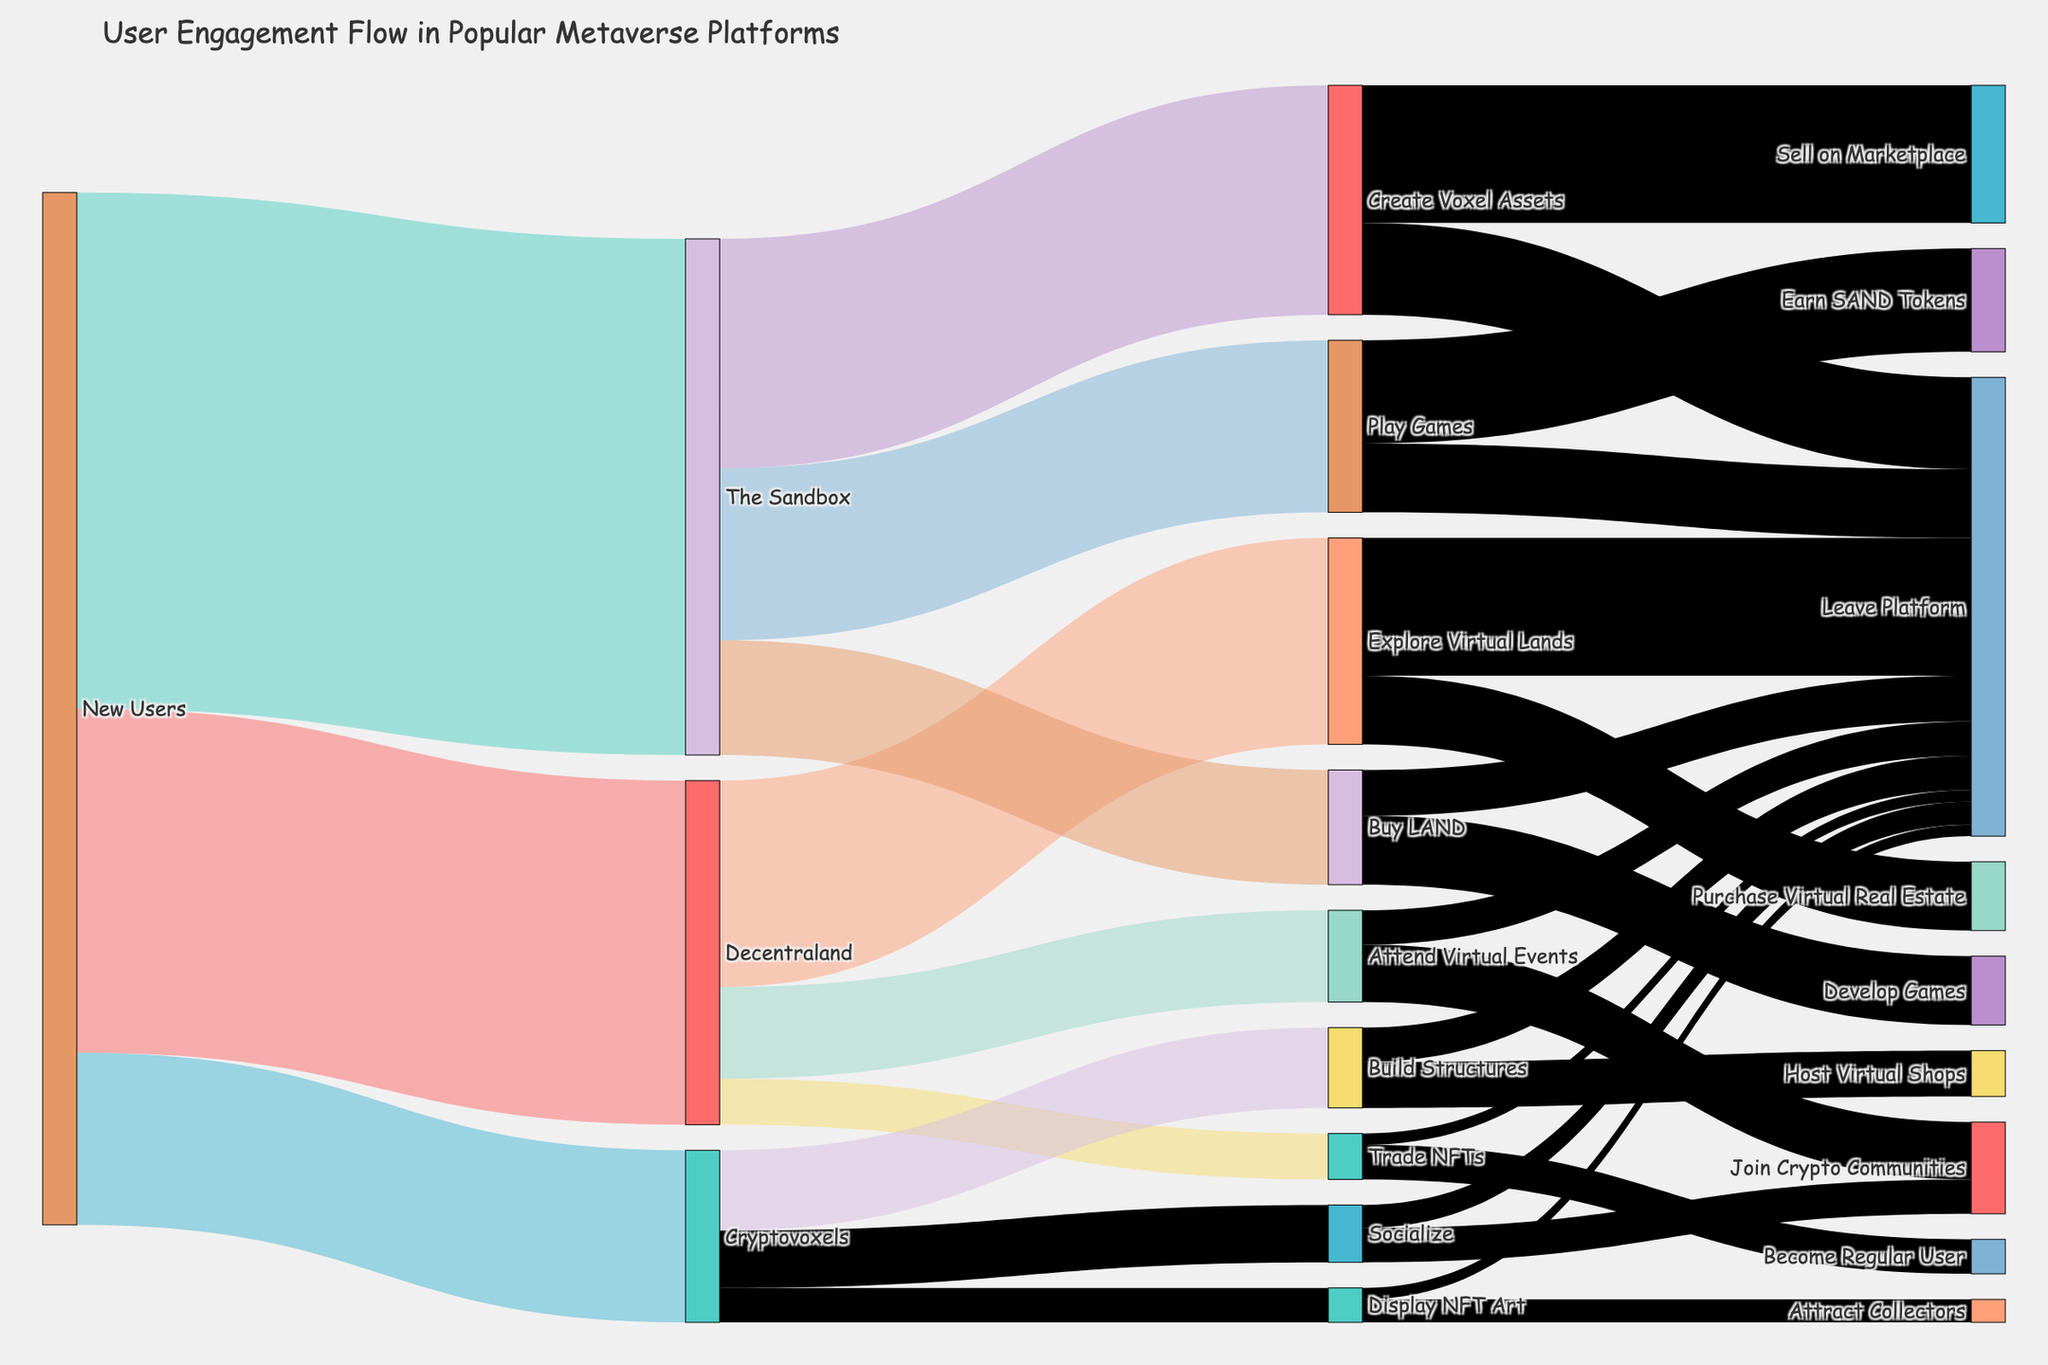What is the title of the figure? The title of the figure is displayed at the top of the Sankey diagram. By reading the top section, you can identify the title.
Answer: User Engagement Flow in Popular Metaverse Platforms Which metaverse platform has the highest number of new users engaging initially? Look for the nodes labeled with the respective metaverse platforms connecting from 'New Users' and compare their values. The node with the highest value indicates the platform with the most new users.
Answer: The Sandbox What is the most common activity for new users in Decentraland? Identify the activities connected from 'Decentraland' and find the one with the highest value.
Answer: Explore Virtual Lands How many users join crypto communities after attending virtual events in Decentraland? Find the node 'Attend Virtual Events' under 'Decentraland' and follow the arrow leading to 'Join Crypto Communities'. Refer to its value.
Answer: 500 What is the total number of new users across all metaverse platforms? Sum the values of new users for all metaverse platforms.
Answer: 9000 Between 'Play Games' and 'Create Voxel Assets' in The Sandbox, which activity has more user engagement? Identify the values connected to 'Play Games' and 'Create Voxel Assets' under 'The Sandbox' and compare them.
Answer: Play Games How many users leave the platform after exploring virtual lands in Decentraland? Locate 'Explore Virtual Lands' and follow the link to 'Leave Platform'. The value of this connection indicates the number of users leaving.
Answer: 1200 What percentage of new users in Decentraland engage in trading NFTs? Divide the number of users trading NFTs by the total number of new users in Decentraland and multiply by 100 to get the percentage. Calculation: (400 / 3000) * 100
Answer: 13.33% Which activity converts the most users into regular users in Decentraland? From the node 'Decentraland', trace connections to activities leading to 'Become Regular User' and find the highest value.
Answer: Trade NFTs How many users display NFT art in Cryptovoxels? Look at the 'Cryptovoxels' node and trace the path leading to 'Display NFT Art'. Refer to its value.
Answer: 300 